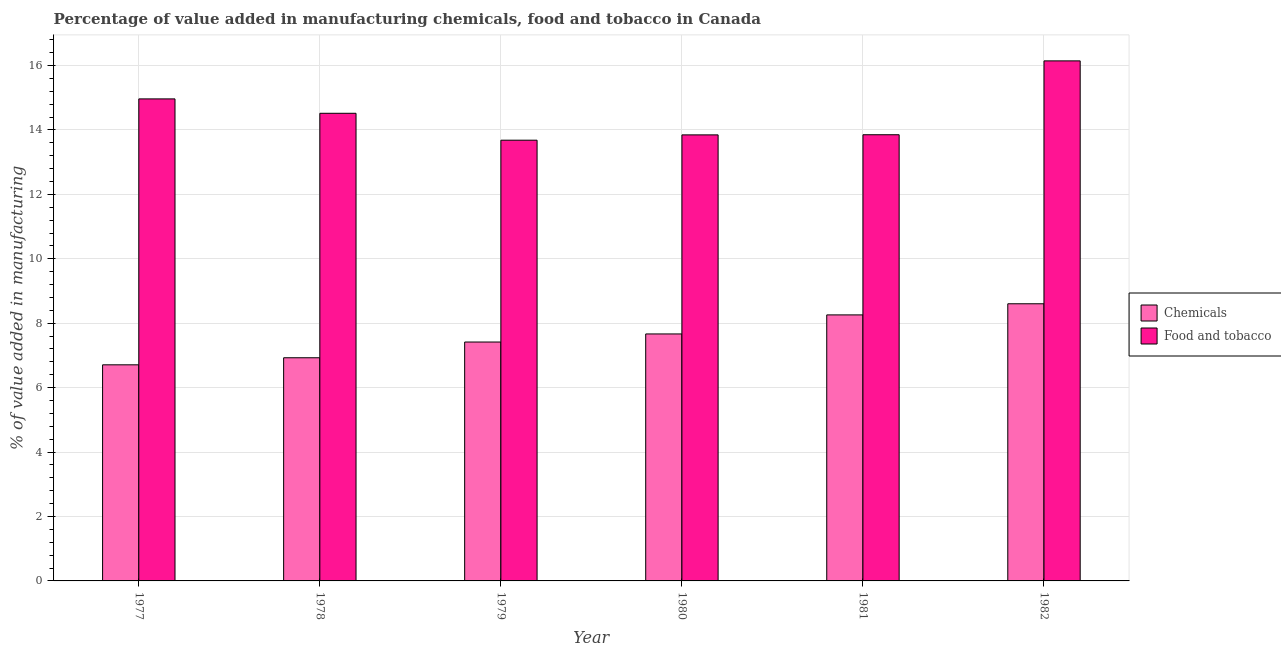How many different coloured bars are there?
Keep it short and to the point. 2. Are the number of bars per tick equal to the number of legend labels?
Your answer should be compact. Yes. What is the value added by manufacturing food and tobacco in 1981?
Offer a terse response. 13.85. Across all years, what is the maximum value added by manufacturing food and tobacco?
Your answer should be very brief. 16.14. Across all years, what is the minimum value added by manufacturing food and tobacco?
Ensure brevity in your answer.  13.68. In which year was the value added by manufacturing food and tobacco minimum?
Your answer should be very brief. 1979. What is the total value added by  manufacturing chemicals in the graph?
Provide a short and direct response. 45.58. What is the difference between the value added by manufacturing food and tobacco in 1977 and that in 1981?
Offer a very short reply. 1.11. What is the difference between the value added by  manufacturing chemicals in 1981 and the value added by manufacturing food and tobacco in 1978?
Your response must be concise. 1.33. What is the average value added by manufacturing food and tobacco per year?
Your response must be concise. 14.5. What is the ratio of the value added by manufacturing food and tobacco in 1977 to that in 1982?
Offer a very short reply. 0.93. What is the difference between the highest and the second highest value added by  manufacturing chemicals?
Offer a very short reply. 0.35. What is the difference between the highest and the lowest value added by  manufacturing chemicals?
Give a very brief answer. 1.9. In how many years, is the value added by  manufacturing chemicals greater than the average value added by  manufacturing chemicals taken over all years?
Ensure brevity in your answer.  3. What does the 2nd bar from the left in 1980 represents?
Give a very brief answer. Food and tobacco. What does the 2nd bar from the right in 1978 represents?
Provide a succinct answer. Chemicals. How many bars are there?
Ensure brevity in your answer.  12. Are all the bars in the graph horizontal?
Your answer should be compact. No. What is the difference between two consecutive major ticks on the Y-axis?
Give a very brief answer. 2. Are the values on the major ticks of Y-axis written in scientific E-notation?
Your answer should be very brief. No. Where does the legend appear in the graph?
Make the answer very short. Center right. How are the legend labels stacked?
Keep it short and to the point. Vertical. What is the title of the graph?
Your answer should be compact. Percentage of value added in manufacturing chemicals, food and tobacco in Canada. What is the label or title of the Y-axis?
Offer a terse response. % of value added in manufacturing. What is the % of value added in manufacturing in Chemicals in 1977?
Your answer should be compact. 6.71. What is the % of value added in manufacturing in Food and tobacco in 1977?
Give a very brief answer. 14.96. What is the % of value added in manufacturing in Chemicals in 1978?
Offer a very short reply. 6.93. What is the % of value added in manufacturing in Food and tobacco in 1978?
Ensure brevity in your answer.  14.52. What is the % of value added in manufacturing in Chemicals in 1979?
Make the answer very short. 7.42. What is the % of value added in manufacturing of Food and tobacco in 1979?
Offer a very short reply. 13.68. What is the % of value added in manufacturing in Chemicals in 1980?
Your response must be concise. 7.67. What is the % of value added in manufacturing of Food and tobacco in 1980?
Ensure brevity in your answer.  13.85. What is the % of value added in manufacturing in Chemicals in 1981?
Your response must be concise. 8.26. What is the % of value added in manufacturing of Food and tobacco in 1981?
Offer a very short reply. 13.85. What is the % of value added in manufacturing in Chemicals in 1982?
Keep it short and to the point. 8.6. What is the % of value added in manufacturing in Food and tobacco in 1982?
Make the answer very short. 16.14. Across all years, what is the maximum % of value added in manufacturing of Chemicals?
Offer a terse response. 8.6. Across all years, what is the maximum % of value added in manufacturing in Food and tobacco?
Offer a very short reply. 16.14. Across all years, what is the minimum % of value added in manufacturing in Chemicals?
Offer a terse response. 6.71. Across all years, what is the minimum % of value added in manufacturing in Food and tobacco?
Provide a succinct answer. 13.68. What is the total % of value added in manufacturing of Chemicals in the graph?
Ensure brevity in your answer.  45.58. What is the total % of value added in manufacturing of Food and tobacco in the graph?
Give a very brief answer. 87. What is the difference between the % of value added in manufacturing in Chemicals in 1977 and that in 1978?
Your answer should be compact. -0.22. What is the difference between the % of value added in manufacturing in Food and tobacco in 1977 and that in 1978?
Your answer should be very brief. 0.45. What is the difference between the % of value added in manufacturing of Chemicals in 1977 and that in 1979?
Provide a short and direct response. -0.71. What is the difference between the % of value added in manufacturing of Food and tobacco in 1977 and that in 1979?
Make the answer very short. 1.28. What is the difference between the % of value added in manufacturing of Chemicals in 1977 and that in 1980?
Your response must be concise. -0.96. What is the difference between the % of value added in manufacturing in Food and tobacco in 1977 and that in 1980?
Offer a terse response. 1.12. What is the difference between the % of value added in manufacturing in Chemicals in 1977 and that in 1981?
Give a very brief answer. -1.55. What is the difference between the % of value added in manufacturing of Food and tobacco in 1977 and that in 1981?
Your response must be concise. 1.11. What is the difference between the % of value added in manufacturing of Chemicals in 1977 and that in 1982?
Your answer should be compact. -1.9. What is the difference between the % of value added in manufacturing in Food and tobacco in 1977 and that in 1982?
Provide a short and direct response. -1.18. What is the difference between the % of value added in manufacturing of Chemicals in 1978 and that in 1979?
Your response must be concise. -0.49. What is the difference between the % of value added in manufacturing of Food and tobacco in 1978 and that in 1979?
Give a very brief answer. 0.84. What is the difference between the % of value added in manufacturing in Chemicals in 1978 and that in 1980?
Your response must be concise. -0.74. What is the difference between the % of value added in manufacturing of Food and tobacco in 1978 and that in 1980?
Provide a short and direct response. 0.67. What is the difference between the % of value added in manufacturing of Chemicals in 1978 and that in 1981?
Provide a succinct answer. -1.33. What is the difference between the % of value added in manufacturing of Food and tobacco in 1978 and that in 1981?
Give a very brief answer. 0.67. What is the difference between the % of value added in manufacturing of Chemicals in 1978 and that in 1982?
Offer a terse response. -1.68. What is the difference between the % of value added in manufacturing of Food and tobacco in 1978 and that in 1982?
Your answer should be compact. -1.63. What is the difference between the % of value added in manufacturing in Chemicals in 1979 and that in 1980?
Keep it short and to the point. -0.25. What is the difference between the % of value added in manufacturing of Food and tobacco in 1979 and that in 1980?
Your answer should be compact. -0.16. What is the difference between the % of value added in manufacturing of Chemicals in 1979 and that in 1981?
Your answer should be compact. -0.84. What is the difference between the % of value added in manufacturing of Food and tobacco in 1979 and that in 1981?
Make the answer very short. -0.17. What is the difference between the % of value added in manufacturing of Chemicals in 1979 and that in 1982?
Your answer should be compact. -1.19. What is the difference between the % of value added in manufacturing in Food and tobacco in 1979 and that in 1982?
Keep it short and to the point. -2.46. What is the difference between the % of value added in manufacturing of Chemicals in 1980 and that in 1981?
Keep it short and to the point. -0.59. What is the difference between the % of value added in manufacturing in Food and tobacco in 1980 and that in 1981?
Your response must be concise. -0. What is the difference between the % of value added in manufacturing of Chemicals in 1980 and that in 1982?
Your answer should be compact. -0.94. What is the difference between the % of value added in manufacturing in Food and tobacco in 1980 and that in 1982?
Your answer should be compact. -2.3. What is the difference between the % of value added in manufacturing in Chemicals in 1981 and that in 1982?
Give a very brief answer. -0.35. What is the difference between the % of value added in manufacturing in Food and tobacco in 1981 and that in 1982?
Provide a succinct answer. -2.29. What is the difference between the % of value added in manufacturing of Chemicals in 1977 and the % of value added in manufacturing of Food and tobacco in 1978?
Provide a short and direct response. -7.81. What is the difference between the % of value added in manufacturing in Chemicals in 1977 and the % of value added in manufacturing in Food and tobacco in 1979?
Your response must be concise. -6.97. What is the difference between the % of value added in manufacturing of Chemicals in 1977 and the % of value added in manufacturing of Food and tobacco in 1980?
Your response must be concise. -7.14. What is the difference between the % of value added in manufacturing in Chemicals in 1977 and the % of value added in manufacturing in Food and tobacco in 1981?
Keep it short and to the point. -7.14. What is the difference between the % of value added in manufacturing in Chemicals in 1977 and the % of value added in manufacturing in Food and tobacco in 1982?
Offer a very short reply. -9.44. What is the difference between the % of value added in manufacturing in Chemicals in 1978 and the % of value added in manufacturing in Food and tobacco in 1979?
Provide a short and direct response. -6.75. What is the difference between the % of value added in manufacturing of Chemicals in 1978 and the % of value added in manufacturing of Food and tobacco in 1980?
Your response must be concise. -6.92. What is the difference between the % of value added in manufacturing in Chemicals in 1978 and the % of value added in manufacturing in Food and tobacco in 1981?
Your response must be concise. -6.92. What is the difference between the % of value added in manufacturing in Chemicals in 1978 and the % of value added in manufacturing in Food and tobacco in 1982?
Keep it short and to the point. -9.22. What is the difference between the % of value added in manufacturing in Chemicals in 1979 and the % of value added in manufacturing in Food and tobacco in 1980?
Make the answer very short. -6.43. What is the difference between the % of value added in manufacturing of Chemicals in 1979 and the % of value added in manufacturing of Food and tobacco in 1981?
Provide a short and direct response. -6.43. What is the difference between the % of value added in manufacturing of Chemicals in 1979 and the % of value added in manufacturing of Food and tobacco in 1982?
Make the answer very short. -8.73. What is the difference between the % of value added in manufacturing in Chemicals in 1980 and the % of value added in manufacturing in Food and tobacco in 1981?
Offer a terse response. -6.18. What is the difference between the % of value added in manufacturing of Chemicals in 1980 and the % of value added in manufacturing of Food and tobacco in 1982?
Your response must be concise. -8.48. What is the difference between the % of value added in manufacturing of Chemicals in 1981 and the % of value added in manufacturing of Food and tobacco in 1982?
Provide a succinct answer. -7.89. What is the average % of value added in manufacturing of Chemicals per year?
Your answer should be compact. 7.6. What is the average % of value added in manufacturing of Food and tobacco per year?
Provide a short and direct response. 14.5. In the year 1977, what is the difference between the % of value added in manufacturing of Chemicals and % of value added in manufacturing of Food and tobacco?
Give a very brief answer. -8.26. In the year 1978, what is the difference between the % of value added in manufacturing in Chemicals and % of value added in manufacturing in Food and tobacco?
Give a very brief answer. -7.59. In the year 1979, what is the difference between the % of value added in manufacturing of Chemicals and % of value added in manufacturing of Food and tobacco?
Keep it short and to the point. -6.27. In the year 1980, what is the difference between the % of value added in manufacturing in Chemicals and % of value added in manufacturing in Food and tobacco?
Give a very brief answer. -6.18. In the year 1981, what is the difference between the % of value added in manufacturing in Chemicals and % of value added in manufacturing in Food and tobacco?
Keep it short and to the point. -5.59. In the year 1982, what is the difference between the % of value added in manufacturing in Chemicals and % of value added in manufacturing in Food and tobacco?
Your answer should be very brief. -7.54. What is the ratio of the % of value added in manufacturing in Chemicals in 1977 to that in 1978?
Your answer should be very brief. 0.97. What is the ratio of the % of value added in manufacturing of Food and tobacco in 1977 to that in 1978?
Provide a succinct answer. 1.03. What is the ratio of the % of value added in manufacturing in Chemicals in 1977 to that in 1979?
Your answer should be compact. 0.9. What is the ratio of the % of value added in manufacturing of Food and tobacco in 1977 to that in 1979?
Give a very brief answer. 1.09. What is the ratio of the % of value added in manufacturing of Food and tobacco in 1977 to that in 1980?
Ensure brevity in your answer.  1.08. What is the ratio of the % of value added in manufacturing of Chemicals in 1977 to that in 1981?
Make the answer very short. 0.81. What is the ratio of the % of value added in manufacturing of Food and tobacco in 1977 to that in 1981?
Offer a terse response. 1.08. What is the ratio of the % of value added in manufacturing of Chemicals in 1977 to that in 1982?
Provide a succinct answer. 0.78. What is the ratio of the % of value added in manufacturing in Food and tobacco in 1977 to that in 1982?
Your answer should be very brief. 0.93. What is the ratio of the % of value added in manufacturing of Chemicals in 1978 to that in 1979?
Give a very brief answer. 0.93. What is the ratio of the % of value added in manufacturing of Food and tobacco in 1978 to that in 1979?
Your response must be concise. 1.06. What is the ratio of the % of value added in manufacturing in Chemicals in 1978 to that in 1980?
Provide a short and direct response. 0.9. What is the ratio of the % of value added in manufacturing of Food and tobacco in 1978 to that in 1980?
Provide a short and direct response. 1.05. What is the ratio of the % of value added in manufacturing of Chemicals in 1978 to that in 1981?
Your response must be concise. 0.84. What is the ratio of the % of value added in manufacturing in Food and tobacco in 1978 to that in 1981?
Ensure brevity in your answer.  1.05. What is the ratio of the % of value added in manufacturing in Chemicals in 1978 to that in 1982?
Your answer should be very brief. 0.81. What is the ratio of the % of value added in manufacturing in Food and tobacco in 1978 to that in 1982?
Provide a succinct answer. 0.9. What is the ratio of the % of value added in manufacturing of Chemicals in 1979 to that in 1980?
Your response must be concise. 0.97. What is the ratio of the % of value added in manufacturing of Food and tobacco in 1979 to that in 1980?
Offer a terse response. 0.99. What is the ratio of the % of value added in manufacturing of Chemicals in 1979 to that in 1981?
Provide a succinct answer. 0.9. What is the ratio of the % of value added in manufacturing of Food and tobacco in 1979 to that in 1981?
Your answer should be compact. 0.99. What is the ratio of the % of value added in manufacturing in Chemicals in 1979 to that in 1982?
Your response must be concise. 0.86. What is the ratio of the % of value added in manufacturing in Food and tobacco in 1979 to that in 1982?
Provide a short and direct response. 0.85. What is the ratio of the % of value added in manufacturing in Chemicals in 1980 to that in 1981?
Offer a terse response. 0.93. What is the ratio of the % of value added in manufacturing of Food and tobacco in 1980 to that in 1981?
Your answer should be compact. 1. What is the ratio of the % of value added in manufacturing in Chemicals in 1980 to that in 1982?
Your response must be concise. 0.89. What is the ratio of the % of value added in manufacturing in Food and tobacco in 1980 to that in 1982?
Offer a terse response. 0.86. What is the ratio of the % of value added in manufacturing in Chemicals in 1981 to that in 1982?
Keep it short and to the point. 0.96. What is the ratio of the % of value added in manufacturing in Food and tobacco in 1981 to that in 1982?
Provide a short and direct response. 0.86. What is the difference between the highest and the second highest % of value added in manufacturing in Chemicals?
Keep it short and to the point. 0.35. What is the difference between the highest and the second highest % of value added in manufacturing of Food and tobacco?
Your answer should be very brief. 1.18. What is the difference between the highest and the lowest % of value added in manufacturing of Chemicals?
Offer a terse response. 1.9. What is the difference between the highest and the lowest % of value added in manufacturing of Food and tobacco?
Offer a very short reply. 2.46. 